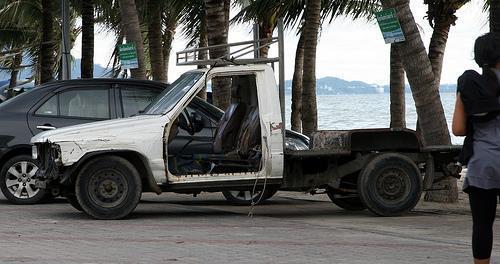How many autos are in the photo?
Give a very brief answer. 2. 